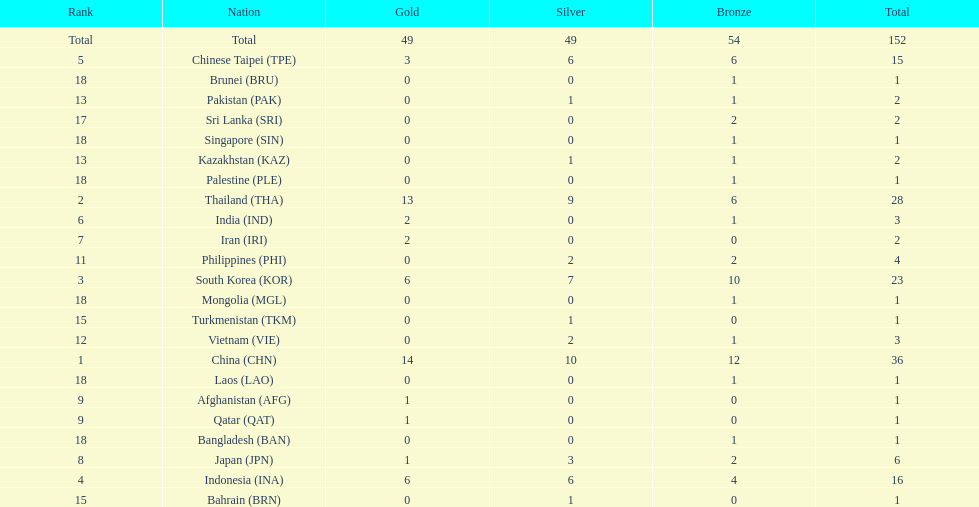How many total gold medal have been given? 49. 